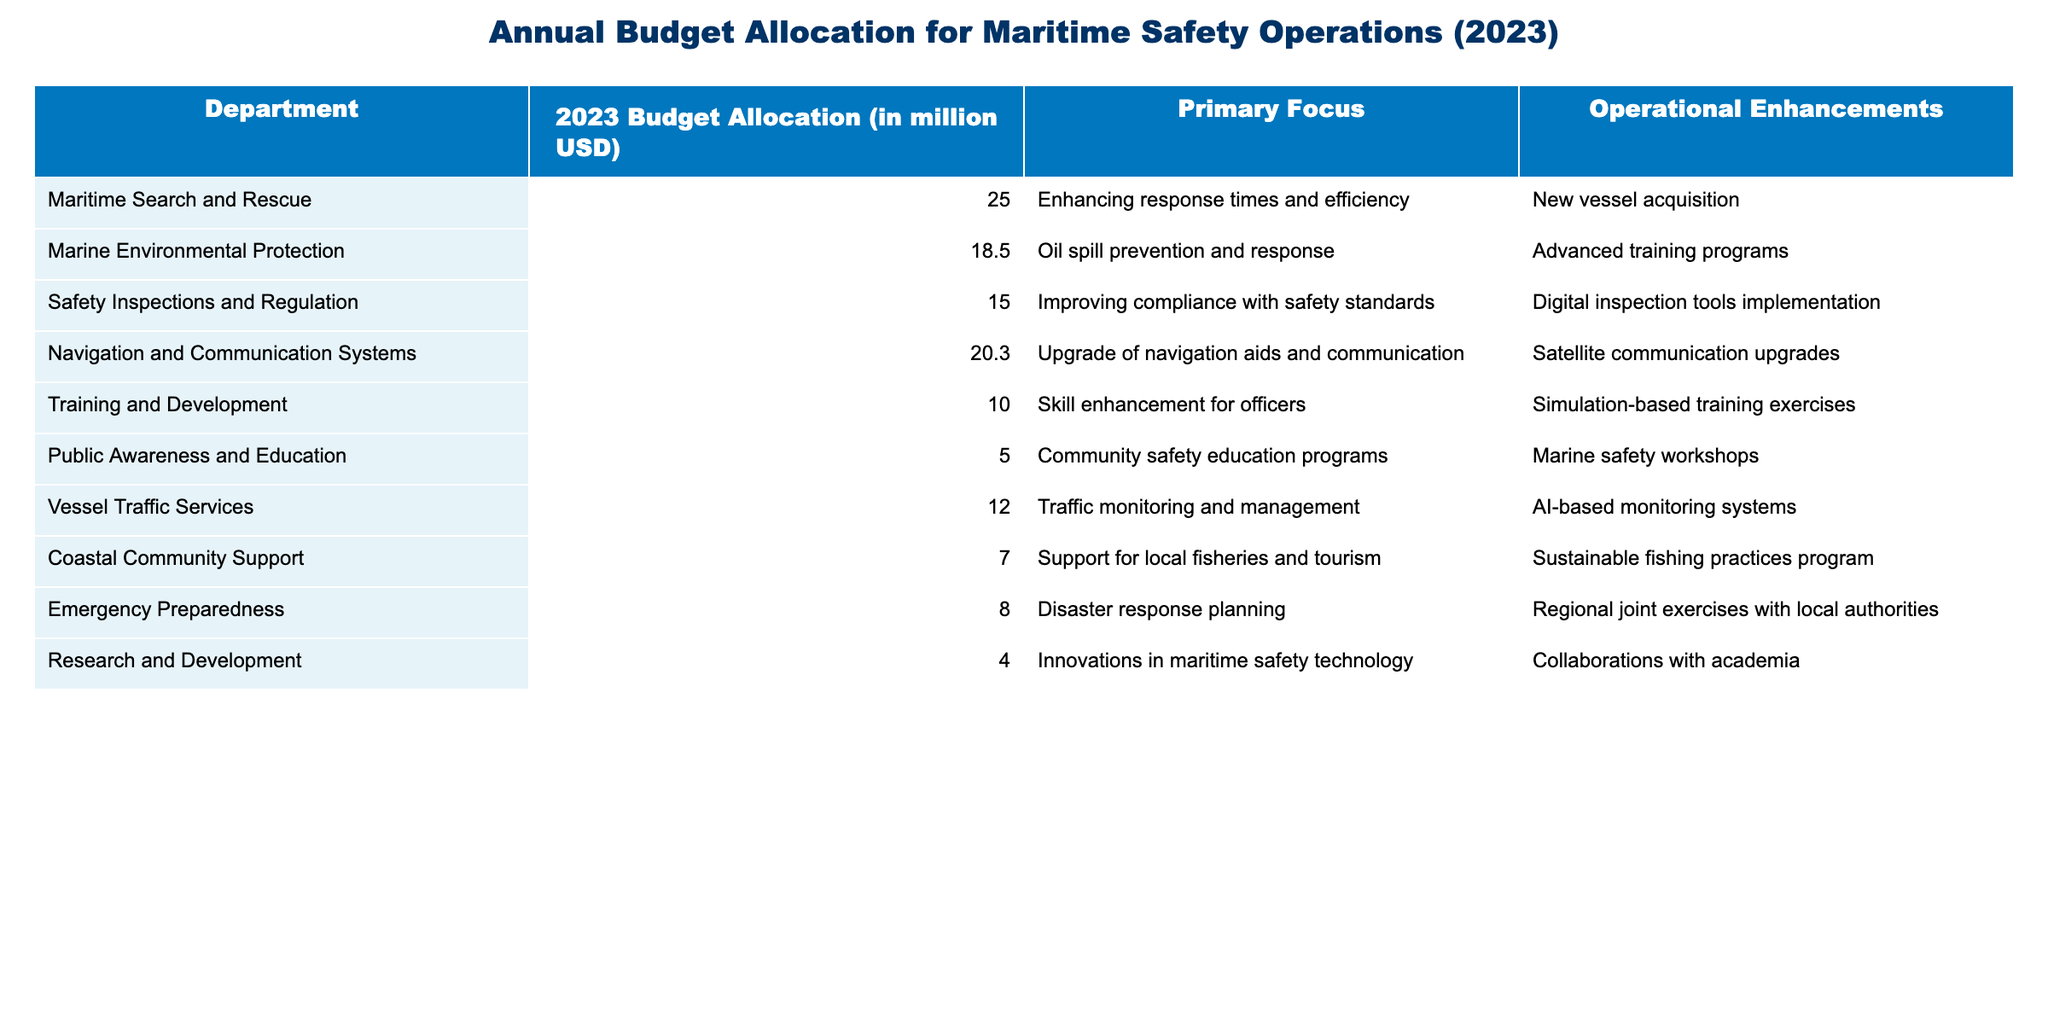What is the budget allocation for Maritime Search and Rescue? The budget allocation for the Maritime Search and Rescue department is explicitly stated in the table. It shows a value of 25.0 million USD for 2023.
Answer: 25.0 million USD Which department has the lowest budget allocation for 2023? By examining the budget allocations for each department listed in the table, Marine Environmental Protection has the lowest allocation of 4.0 million USD for 2023.
Answer: 4.0 million USD What is the total budget allocation for all departments? To find the total budget allocation, we need to sum the allocations: 25.0 + 18.5 + 15.0 + 20.3 + 10.0 + 5.0 + 12.0 + 7.0 + 8.0 + 4.0 = 125.8 million USD.
Answer: 125.8 million USD How much more is allocated to Navigation and Communication Systems compared to Training and Development? The allocation for Navigation and Communication Systems is 20.3 million USD and for Training and Development is 10.0 million USD. The difference is 20.3 - 10.0 = 10.3 million USD.
Answer: 10.3 million USD What percentage of the total budget is allocated to Public Awareness and Education? The total budget allocation is 125.8 million USD and the allocation for Public Awareness and Education is 5.0 million USD. To find the percentage, (5.0/125.8) * 100 = 3.98%, approximately 4%.
Answer: 4% Does Coastal Community Support have a higher budget allocation than Emergency Preparedness? Looking at the table entries, Coastal Community Support has an allocation of 7.0 million USD, while Emergency Preparedness has an allocation of 8.0 million USD. Therefore, it's false that Coastal Community Support has a higher allocation.
Answer: No What is the average budget allocation across all departments? To find the average, sum all the allocations (125.8 million USD) and then divide by the number of departments (10): 125.8 / 10 = 12.58 million USD.
Answer: 12.58 million USD Which department has a budget allocation that is at least 20 million USD but less than 30 million USD? Checking the allocations, only the Maritime Search and Rescue department fits this criterion with 25.0 million USD allocated.
Answer: Maritime Search and Rescue How much budget is dedicated to both Vessel Traffic Services and Coastal Community Support combined? The budget for Vessel Traffic Services is 12.0 million USD and for Coastal Community Support is 7.0 million USD. Adding them together gives 12.0 + 7.0 = 19.0 million USD.
Answer: 19.0 million USD Is the focus of the Marine Environmental Protection department on oil spill response? The table indicates that the primary focus of the Marine Environmental Protection department is indeed oil spill prevention and response, confirming that the statement is true.
Answer: Yes 